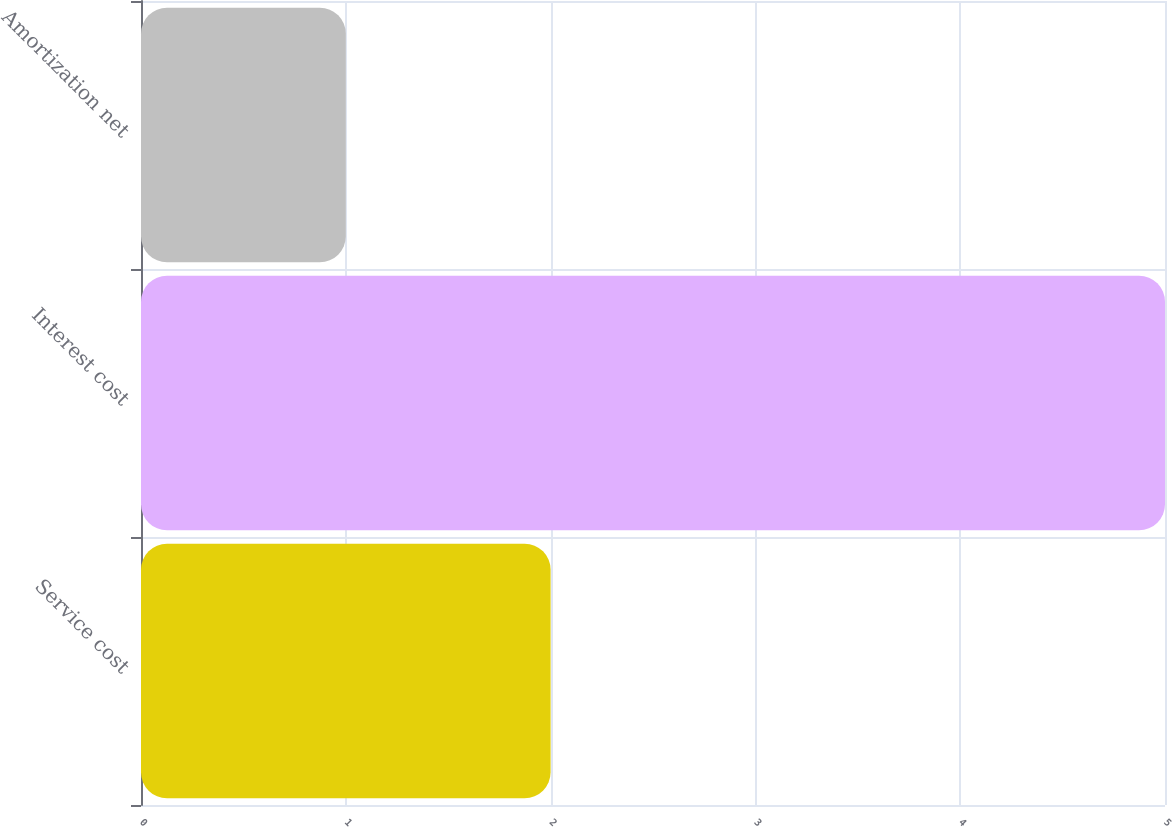Convert chart. <chart><loc_0><loc_0><loc_500><loc_500><bar_chart><fcel>Service cost<fcel>Interest cost<fcel>Amortization net<nl><fcel>2<fcel>5<fcel>1<nl></chart> 